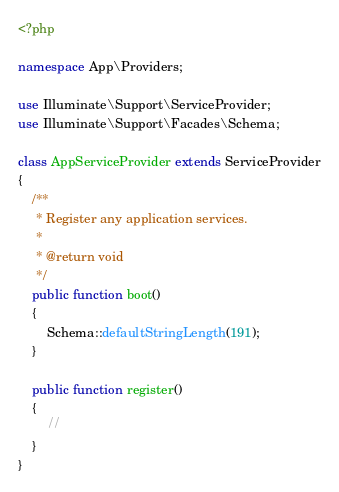Convert code to text. <code><loc_0><loc_0><loc_500><loc_500><_PHP_><?php

namespace App\Providers;

use Illuminate\Support\ServiceProvider;
use Illuminate\Support\Facades\Schema;

class AppServiceProvider extends ServiceProvider
{
    /**
     * Register any application services.
     *
     * @return void
     */
    public function boot()
    {
        Schema::defaultStringLength(191);
    }

    public function register()
    {
        //
    }
}
</code> 